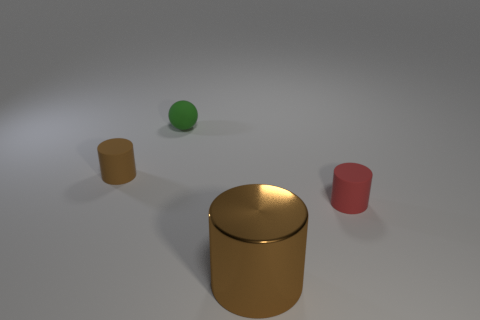How many tiny things are metallic things or green shiny cylinders?
Give a very brief answer. 0. Is the tiny rubber ball the same color as the large thing?
Keep it short and to the point. No. Is the number of large brown cylinders that are in front of the shiny thing greater than the number of brown things in front of the red thing?
Provide a succinct answer. No. There is a cylinder to the left of the large brown cylinder; is it the same color as the large cylinder?
Offer a very short reply. Yes. Is there anything else that is the same color as the large shiny object?
Give a very brief answer. Yes. Are there more cylinders that are to the left of the big thing than brown balls?
Your response must be concise. Yes. Does the green rubber ball have the same size as the shiny cylinder?
Give a very brief answer. No. What is the material of the other small thing that is the same shape as the red matte thing?
Your response must be concise. Rubber. Is there any other thing that is made of the same material as the sphere?
Provide a short and direct response. Yes. What number of red objects are either small matte cylinders or metallic things?
Your answer should be compact. 1. 